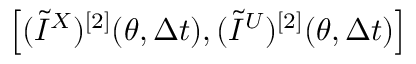Convert formula to latex. <formula><loc_0><loc_0><loc_500><loc_500>\left [ ( \widetilde { I } ^ { X } ) ^ { [ 2 ] } ( \theta , \Delta t ) , ( \widetilde { I } ^ { U } ) ^ { [ 2 ] } ( \theta , \Delta t ) \right ]</formula> 